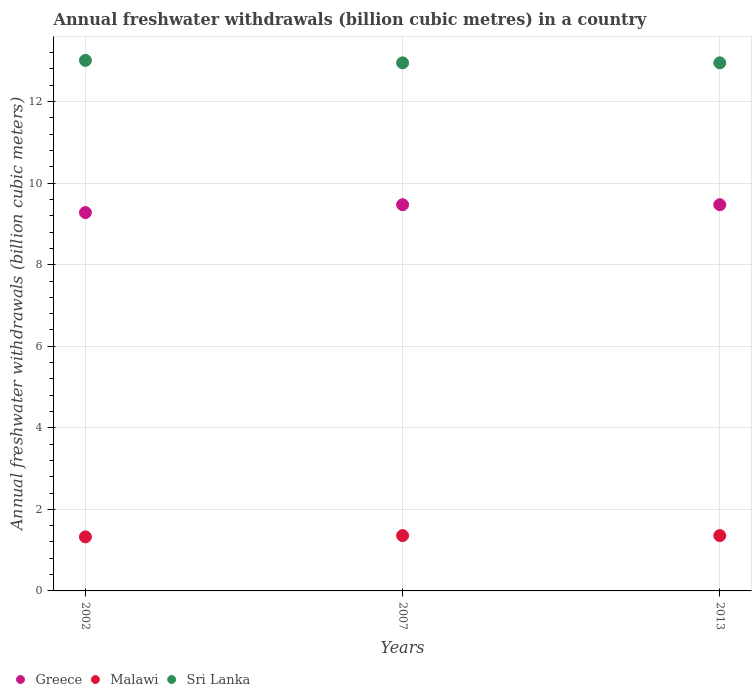What is the annual freshwater withdrawals in Sri Lanka in 2013?
Your answer should be very brief. 12.95. Across all years, what is the maximum annual freshwater withdrawals in Sri Lanka?
Ensure brevity in your answer.  13.01. Across all years, what is the minimum annual freshwater withdrawals in Sri Lanka?
Your response must be concise. 12.95. In which year was the annual freshwater withdrawals in Malawi maximum?
Keep it short and to the point. 2007. In which year was the annual freshwater withdrawals in Malawi minimum?
Provide a short and direct response. 2002. What is the total annual freshwater withdrawals in Sri Lanka in the graph?
Provide a succinct answer. 38.91. What is the difference between the annual freshwater withdrawals in Sri Lanka in 2002 and that in 2007?
Your response must be concise. 0.06. What is the difference between the annual freshwater withdrawals in Malawi in 2002 and the annual freshwater withdrawals in Sri Lanka in 2013?
Offer a very short reply. -11.62. What is the average annual freshwater withdrawals in Malawi per year?
Your answer should be very brief. 1.35. In the year 2002, what is the difference between the annual freshwater withdrawals in Sri Lanka and annual freshwater withdrawals in Malawi?
Your response must be concise. 11.69. In how many years, is the annual freshwater withdrawals in Malawi greater than 10.4 billion cubic meters?
Provide a short and direct response. 0. What is the ratio of the annual freshwater withdrawals in Malawi in 2002 to that in 2007?
Your response must be concise. 0.98. Is the annual freshwater withdrawals in Sri Lanka in 2007 less than that in 2013?
Offer a terse response. No. Is the difference between the annual freshwater withdrawals in Sri Lanka in 2002 and 2013 greater than the difference between the annual freshwater withdrawals in Malawi in 2002 and 2013?
Provide a succinct answer. Yes. What is the difference between the highest and the second highest annual freshwater withdrawals in Malawi?
Make the answer very short. 0. What is the difference between the highest and the lowest annual freshwater withdrawals in Greece?
Your answer should be compact. 0.19. In how many years, is the annual freshwater withdrawals in Sri Lanka greater than the average annual freshwater withdrawals in Sri Lanka taken over all years?
Ensure brevity in your answer.  1. Is the annual freshwater withdrawals in Sri Lanka strictly less than the annual freshwater withdrawals in Malawi over the years?
Your answer should be very brief. No. Does the graph contain any zero values?
Provide a short and direct response. No. How many legend labels are there?
Offer a terse response. 3. How are the legend labels stacked?
Offer a very short reply. Horizontal. What is the title of the graph?
Keep it short and to the point. Annual freshwater withdrawals (billion cubic metres) in a country. What is the label or title of the Y-axis?
Your answer should be very brief. Annual freshwater withdrawals (billion cubic meters). What is the Annual freshwater withdrawals (billion cubic meters) in Greece in 2002?
Make the answer very short. 9.28. What is the Annual freshwater withdrawals (billion cubic meters) in Malawi in 2002?
Offer a very short reply. 1.32. What is the Annual freshwater withdrawals (billion cubic meters) of Sri Lanka in 2002?
Offer a terse response. 13.01. What is the Annual freshwater withdrawals (billion cubic meters) in Greece in 2007?
Provide a succinct answer. 9.47. What is the Annual freshwater withdrawals (billion cubic meters) of Malawi in 2007?
Offer a terse response. 1.36. What is the Annual freshwater withdrawals (billion cubic meters) of Sri Lanka in 2007?
Your answer should be very brief. 12.95. What is the Annual freshwater withdrawals (billion cubic meters) of Greece in 2013?
Offer a terse response. 9.47. What is the Annual freshwater withdrawals (billion cubic meters) of Malawi in 2013?
Offer a very short reply. 1.36. What is the Annual freshwater withdrawals (billion cubic meters) of Sri Lanka in 2013?
Provide a succinct answer. 12.95. Across all years, what is the maximum Annual freshwater withdrawals (billion cubic meters) in Greece?
Give a very brief answer. 9.47. Across all years, what is the maximum Annual freshwater withdrawals (billion cubic meters) of Malawi?
Your response must be concise. 1.36. Across all years, what is the maximum Annual freshwater withdrawals (billion cubic meters) of Sri Lanka?
Keep it short and to the point. 13.01. Across all years, what is the minimum Annual freshwater withdrawals (billion cubic meters) of Greece?
Provide a succinct answer. 9.28. Across all years, what is the minimum Annual freshwater withdrawals (billion cubic meters) in Malawi?
Provide a short and direct response. 1.32. Across all years, what is the minimum Annual freshwater withdrawals (billion cubic meters) in Sri Lanka?
Offer a terse response. 12.95. What is the total Annual freshwater withdrawals (billion cubic meters) in Greece in the graph?
Offer a very short reply. 28.22. What is the total Annual freshwater withdrawals (billion cubic meters) in Malawi in the graph?
Provide a short and direct response. 4.04. What is the total Annual freshwater withdrawals (billion cubic meters) of Sri Lanka in the graph?
Provide a succinct answer. 38.91. What is the difference between the Annual freshwater withdrawals (billion cubic meters) of Greece in 2002 and that in 2007?
Give a very brief answer. -0.19. What is the difference between the Annual freshwater withdrawals (billion cubic meters) in Malawi in 2002 and that in 2007?
Provide a succinct answer. -0.03. What is the difference between the Annual freshwater withdrawals (billion cubic meters) of Greece in 2002 and that in 2013?
Offer a very short reply. -0.19. What is the difference between the Annual freshwater withdrawals (billion cubic meters) in Malawi in 2002 and that in 2013?
Keep it short and to the point. -0.03. What is the difference between the Annual freshwater withdrawals (billion cubic meters) of Greece in 2007 and that in 2013?
Your response must be concise. 0. What is the difference between the Annual freshwater withdrawals (billion cubic meters) in Malawi in 2007 and that in 2013?
Keep it short and to the point. 0. What is the difference between the Annual freshwater withdrawals (billion cubic meters) in Sri Lanka in 2007 and that in 2013?
Offer a very short reply. 0. What is the difference between the Annual freshwater withdrawals (billion cubic meters) of Greece in 2002 and the Annual freshwater withdrawals (billion cubic meters) of Malawi in 2007?
Keep it short and to the point. 7.92. What is the difference between the Annual freshwater withdrawals (billion cubic meters) of Greece in 2002 and the Annual freshwater withdrawals (billion cubic meters) of Sri Lanka in 2007?
Your answer should be very brief. -3.67. What is the difference between the Annual freshwater withdrawals (billion cubic meters) of Malawi in 2002 and the Annual freshwater withdrawals (billion cubic meters) of Sri Lanka in 2007?
Offer a very short reply. -11.62. What is the difference between the Annual freshwater withdrawals (billion cubic meters) of Greece in 2002 and the Annual freshwater withdrawals (billion cubic meters) of Malawi in 2013?
Offer a very short reply. 7.92. What is the difference between the Annual freshwater withdrawals (billion cubic meters) in Greece in 2002 and the Annual freshwater withdrawals (billion cubic meters) in Sri Lanka in 2013?
Ensure brevity in your answer.  -3.67. What is the difference between the Annual freshwater withdrawals (billion cubic meters) of Malawi in 2002 and the Annual freshwater withdrawals (billion cubic meters) of Sri Lanka in 2013?
Provide a short and direct response. -11.62. What is the difference between the Annual freshwater withdrawals (billion cubic meters) of Greece in 2007 and the Annual freshwater withdrawals (billion cubic meters) of Malawi in 2013?
Your response must be concise. 8.11. What is the difference between the Annual freshwater withdrawals (billion cubic meters) in Greece in 2007 and the Annual freshwater withdrawals (billion cubic meters) in Sri Lanka in 2013?
Offer a terse response. -3.48. What is the difference between the Annual freshwater withdrawals (billion cubic meters) in Malawi in 2007 and the Annual freshwater withdrawals (billion cubic meters) in Sri Lanka in 2013?
Give a very brief answer. -11.59. What is the average Annual freshwater withdrawals (billion cubic meters) of Greece per year?
Your answer should be compact. 9.41. What is the average Annual freshwater withdrawals (billion cubic meters) of Malawi per year?
Offer a very short reply. 1.35. What is the average Annual freshwater withdrawals (billion cubic meters) of Sri Lanka per year?
Your answer should be very brief. 12.97. In the year 2002, what is the difference between the Annual freshwater withdrawals (billion cubic meters) of Greece and Annual freshwater withdrawals (billion cubic meters) of Malawi?
Keep it short and to the point. 7.95. In the year 2002, what is the difference between the Annual freshwater withdrawals (billion cubic meters) of Greece and Annual freshwater withdrawals (billion cubic meters) of Sri Lanka?
Make the answer very short. -3.73. In the year 2002, what is the difference between the Annual freshwater withdrawals (billion cubic meters) in Malawi and Annual freshwater withdrawals (billion cubic meters) in Sri Lanka?
Make the answer very short. -11.69. In the year 2007, what is the difference between the Annual freshwater withdrawals (billion cubic meters) of Greece and Annual freshwater withdrawals (billion cubic meters) of Malawi?
Offer a terse response. 8.11. In the year 2007, what is the difference between the Annual freshwater withdrawals (billion cubic meters) of Greece and Annual freshwater withdrawals (billion cubic meters) of Sri Lanka?
Your response must be concise. -3.48. In the year 2007, what is the difference between the Annual freshwater withdrawals (billion cubic meters) of Malawi and Annual freshwater withdrawals (billion cubic meters) of Sri Lanka?
Your response must be concise. -11.59. In the year 2013, what is the difference between the Annual freshwater withdrawals (billion cubic meters) of Greece and Annual freshwater withdrawals (billion cubic meters) of Malawi?
Your answer should be very brief. 8.11. In the year 2013, what is the difference between the Annual freshwater withdrawals (billion cubic meters) of Greece and Annual freshwater withdrawals (billion cubic meters) of Sri Lanka?
Offer a very short reply. -3.48. In the year 2013, what is the difference between the Annual freshwater withdrawals (billion cubic meters) in Malawi and Annual freshwater withdrawals (billion cubic meters) in Sri Lanka?
Keep it short and to the point. -11.59. What is the ratio of the Annual freshwater withdrawals (billion cubic meters) of Greece in 2002 to that in 2007?
Ensure brevity in your answer.  0.98. What is the ratio of the Annual freshwater withdrawals (billion cubic meters) of Malawi in 2002 to that in 2007?
Keep it short and to the point. 0.98. What is the ratio of the Annual freshwater withdrawals (billion cubic meters) in Greece in 2002 to that in 2013?
Keep it short and to the point. 0.98. What is the ratio of the Annual freshwater withdrawals (billion cubic meters) in Malawi in 2002 to that in 2013?
Provide a short and direct response. 0.98. What is the ratio of the Annual freshwater withdrawals (billion cubic meters) in Malawi in 2007 to that in 2013?
Make the answer very short. 1. What is the ratio of the Annual freshwater withdrawals (billion cubic meters) in Sri Lanka in 2007 to that in 2013?
Offer a very short reply. 1. What is the difference between the highest and the second highest Annual freshwater withdrawals (billion cubic meters) in Greece?
Your response must be concise. 0. What is the difference between the highest and the second highest Annual freshwater withdrawals (billion cubic meters) of Sri Lanka?
Your answer should be very brief. 0.06. What is the difference between the highest and the lowest Annual freshwater withdrawals (billion cubic meters) of Greece?
Give a very brief answer. 0.19. What is the difference between the highest and the lowest Annual freshwater withdrawals (billion cubic meters) of Malawi?
Offer a very short reply. 0.03. 